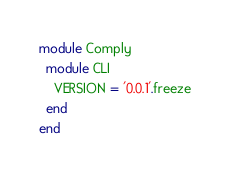<code> <loc_0><loc_0><loc_500><loc_500><_Ruby_>module Comply
  module CLI
    VERSION = '0.0.1'.freeze
  end
end
</code> 